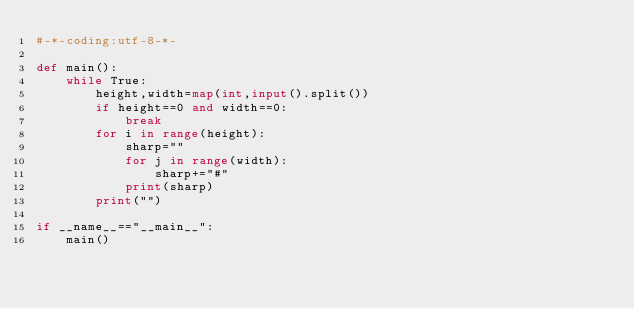<code> <loc_0><loc_0><loc_500><loc_500><_Python_>#-*-coding:utf-8-*-

def main():
    while True:
        height,width=map(int,input().split())
        if height==0 and width==0:
            break
        for i in range(height):
            sharp=""
            for j in range(width):
                sharp+="#"
            print(sharp)
        print("")
            
if __name__=="__main__":
    main()
</code> 